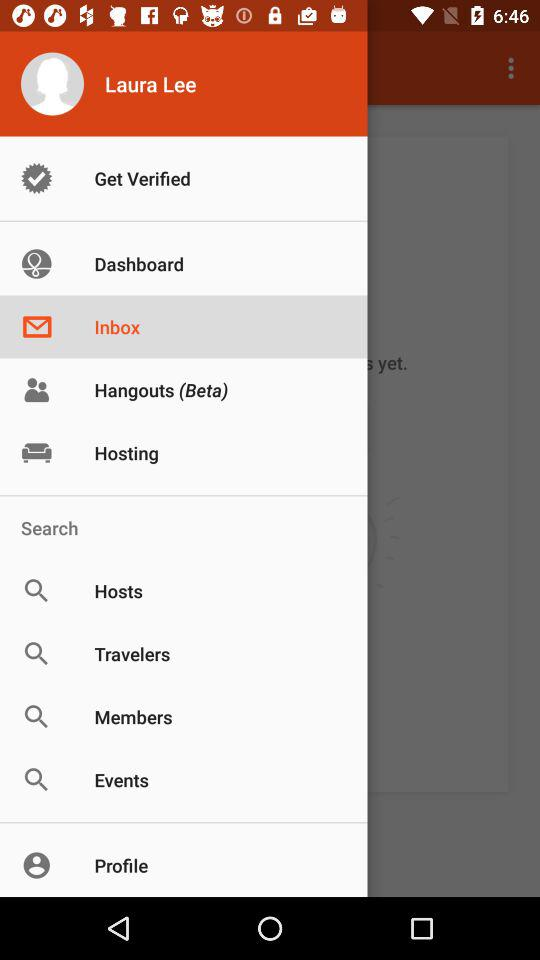What is the user name? The user name is Laura Lee. 